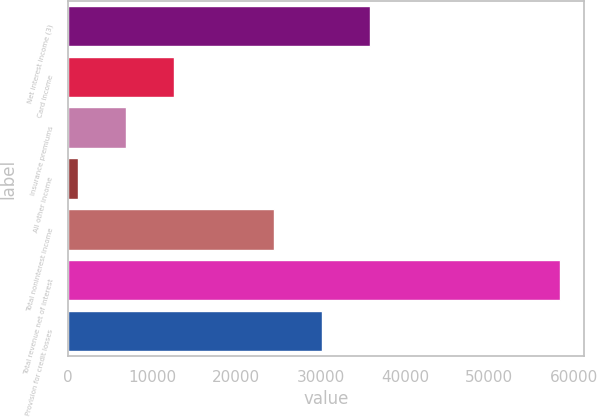Convert chart to OTSL. <chart><loc_0><loc_0><loc_500><loc_500><bar_chart><fcel>Net interest income (3)<fcel>Card income<fcel>Insurance premiums<fcel>All other income<fcel>Total noninterest income<fcel>Total revenue net of interest<fcel>Provision for credit losses<nl><fcel>35914<fcel>12660<fcel>6949.5<fcel>1239<fcel>24493<fcel>58344<fcel>30203.5<nl></chart> 